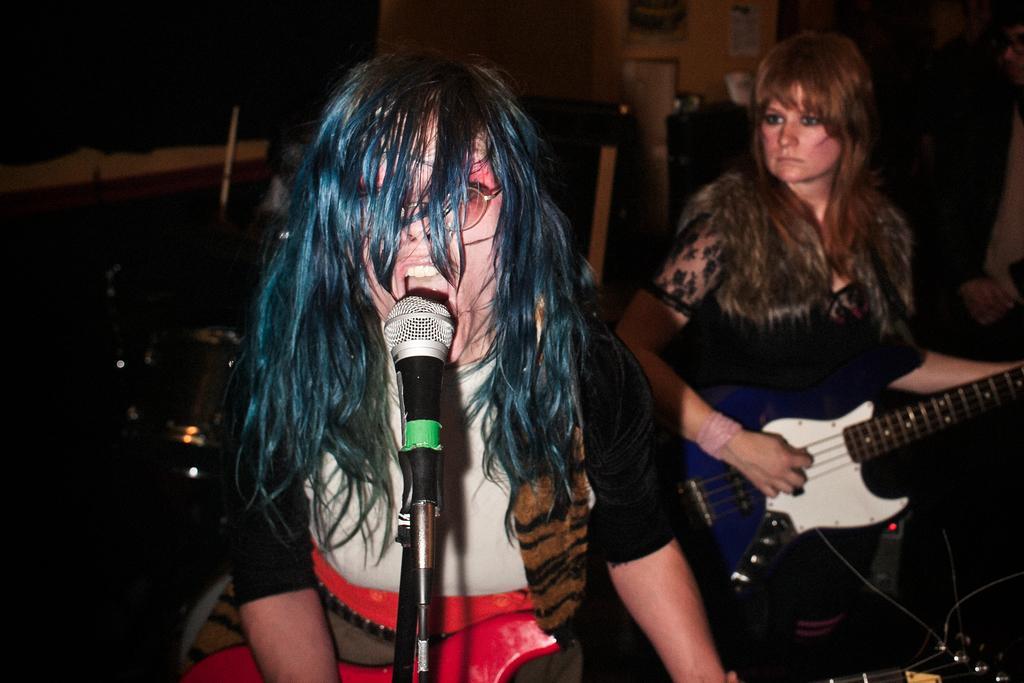Please provide a concise description of this image. In this image there is a woman standing and singing a song in the microphone , another woman playing a guitar and in the back ground there is a chair and a table , photo frame attached to the wall. 